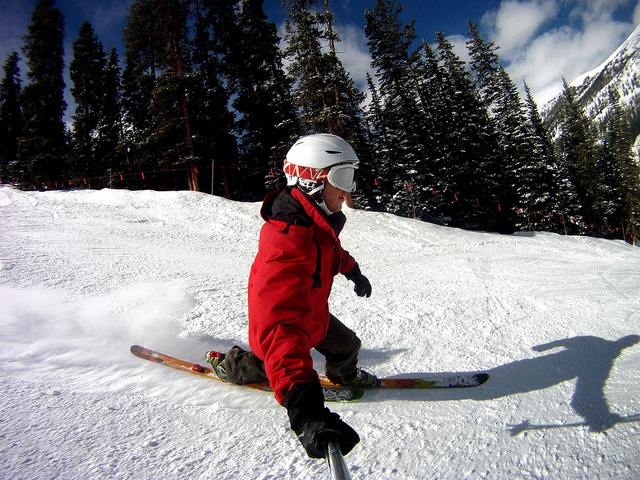Describe the objects in this image and their specific colors. I can see people in navy, black, maroon, red, and brown tones and skis in navy, gray, black, darkgray, and maroon tones in this image. 